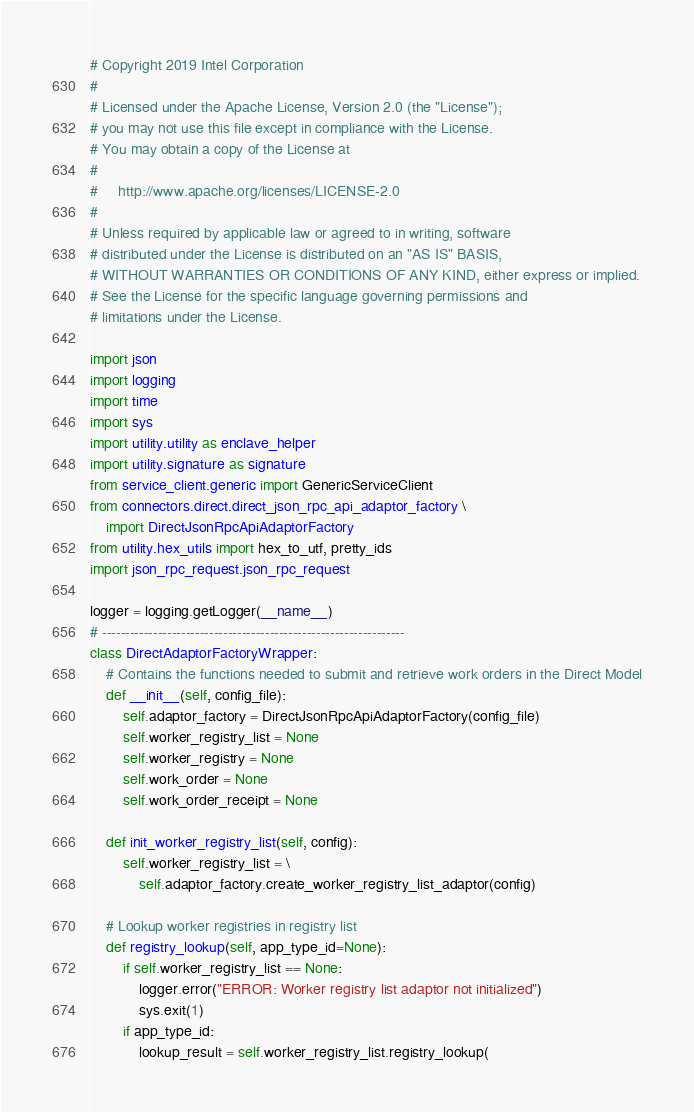Convert code to text. <code><loc_0><loc_0><loc_500><loc_500><_Python_># Copyright 2019 Intel Corporation
#
# Licensed under the Apache License, Version 2.0 (the "License");
# you may not use this file except in compliance with the License.
# You may obtain a copy of the License at
#
#     http://www.apache.org/licenses/LICENSE-2.0
#
# Unless required by applicable law or agreed to in writing, software
# distributed under the License is distributed on an "AS IS" BASIS,
# WITHOUT WARRANTIES OR CONDITIONS OF ANY KIND, either express or implied.
# See the License for the specific language governing permissions and
# limitations under the License.

import json
import logging
import time
import sys
import utility.utility as enclave_helper
import utility.signature as signature
from service_client.generic import GenericServiceClient
from connectors.direct.direct_json_rpc_api_adaptor_factory \
	import DirectJsonRpcApiAdaptorFactory
from utility.hex_utils import hex_to_utf, pretty_ids
import json_rpc_request.json_rpc_request

logger = logging.getLogger(__name__)
# -----------------------------------------------------------------
class DirectAdaptorFactoryWrapper:
	# Contains the functions needed to submit and retrieve work orders in the Direct Model
	def __init__(self, config_file):
		self.adaptor_factory = DirectJsonRpcApiAdaptorFactory(config_file)
		self.worker_registry_list = None
		self.worker_registry = None
		self.work_order = None
		self.work_order_receipt = None

	def init_worker_registry_list(self, config):
		self.worker_registry_list = \
			self.adaptor_factory.create_worker_registry_list_adaptor(config)

	# Lookup worker registries in registry list
	def registry_lookup(self, app_type_id=None):
		if self.worker_registry_list == None:
			logger.error("ERROR: Worker registry list adaptor not initialized")
			sys.exit(1)
		if app_type_id:
			lookup_result = self.worker_registry_list.registry_lookup(</code> 